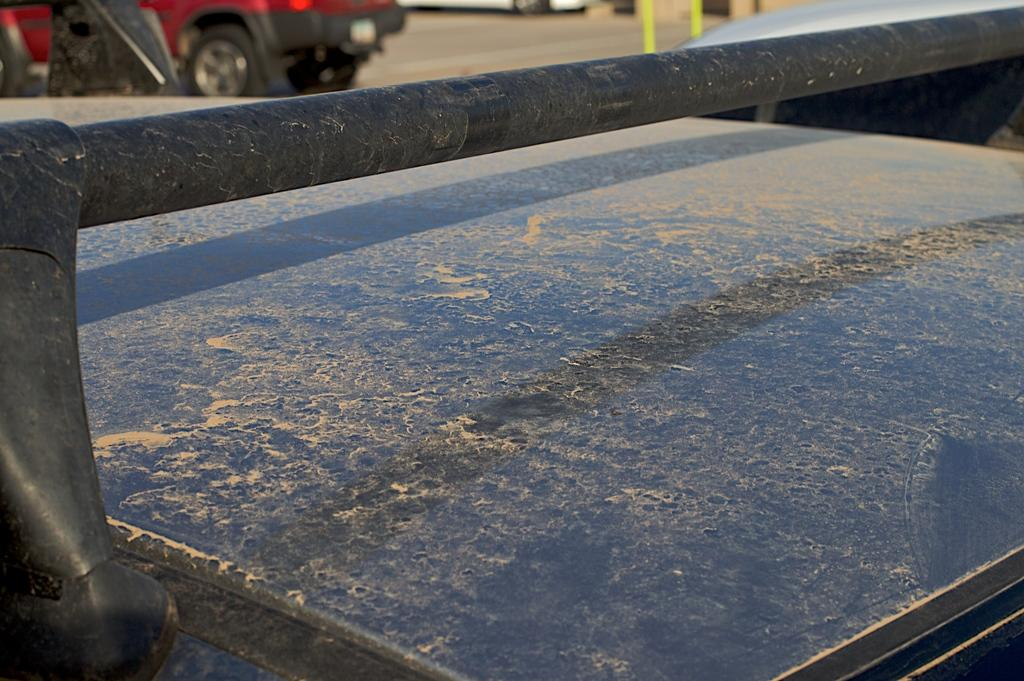What part of a car can be seen at the bottom of the image? The top of a car is visible at the bottom of the image. Are there any other vehicles in the image? Yes, there is another car in the background of the image. Where is the second car located? The car in the background is parked on the road. What type of tongue can be seen sticking out of the car in the background? There is no tongue visible in the image; it features cars and their locations. 